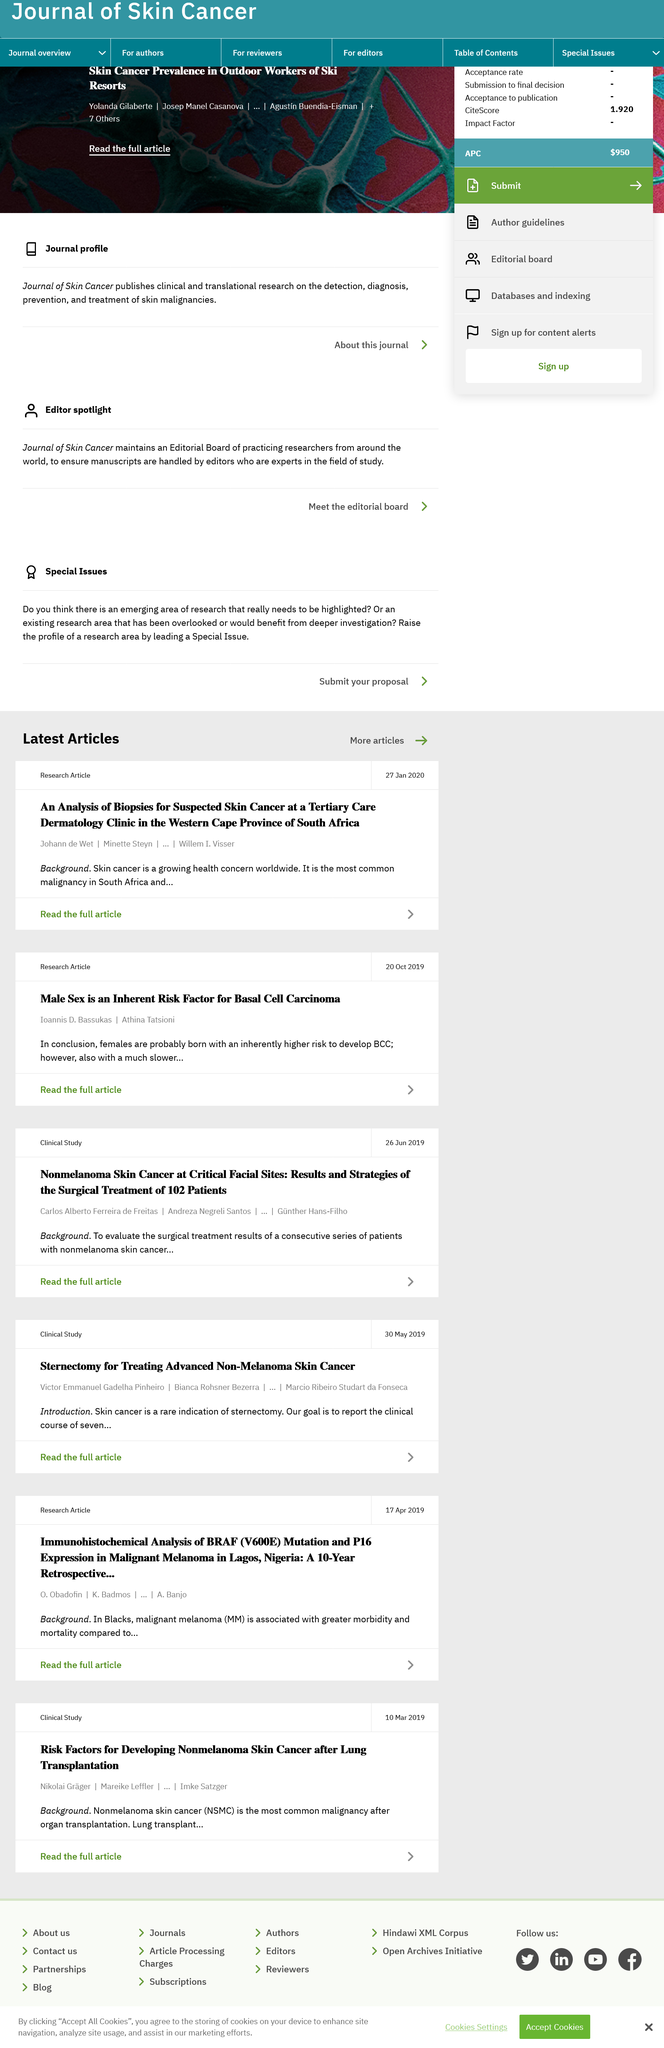Identify some key points in this picture. Basal Cell Carcinoma is a type of skin cancer that is characterized by the uncontrolled growth of abnormal cells in the basal cells of the skin. These abnormal cells can form a tumor and can invade other tissues and organs if not treated properly. Basal Cell Carcinoma is the most common type of skin cancer and is usually caused by exposure to ultraviolet radiation from the sun or artificial sources. Early detection and treatment are essential to prevent the spread of Basal Cell Carcinoma and to ensure a good prognosis. The research article was published on October 20, 2019. The most common malignancy in South Africa is skin cancer. 